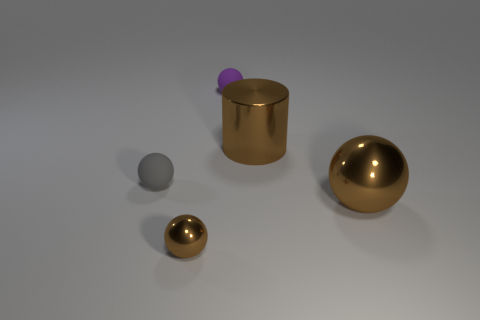Subtract all large balls. How many balls are left? 3 Subtract 2 spheres. How many spheres are left? 2 Add 2 small red objects. How many objects exist? 7 Subtract all blue balls. Subtract all red cubes. How many balls are left? 4 Subtract all cylinders. How many objects are left? 4 Add 1 rubber things. How many rubber things are left? 3 Add 4 big brown things. How many big brown things exist? 6 Subtract 0 cyan blocks. How many objects are left? 5 Subtract all purple things. Subtract all tiny blue blocks. How many objects are left? 4 